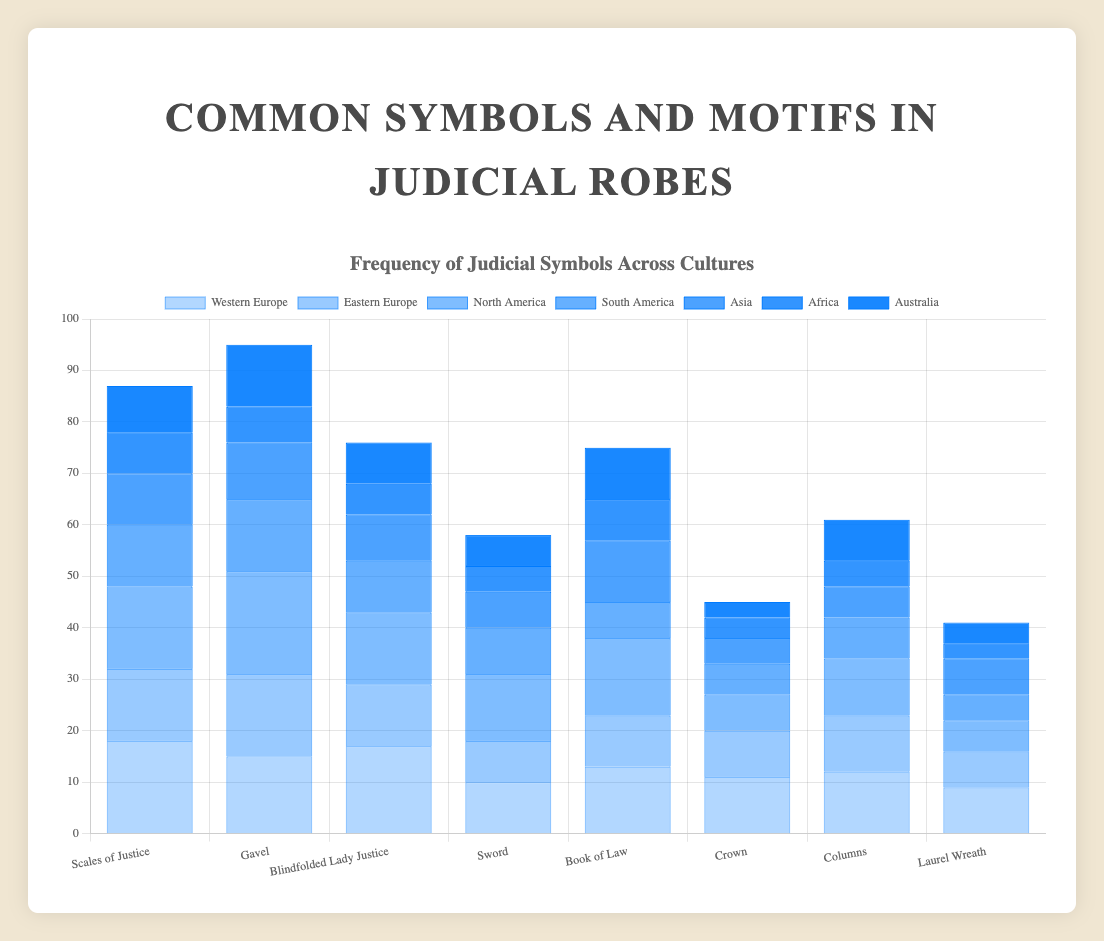Which culture features the "Scales of Justice" most frequently? By looking at the bars for the "Scales of Justice" symbol, we note the tallest bar represents Western Europe.
Answer: Western Europe Which symbol appears the least frequently overall? Scan across all symbols and their frequencies; the "Crown" has the consistently smallest values overall.
Answer: Crown What are the average frequencies of the "Book of Law" across all cultures? Sum up the frequencies for "Book of Law" across all regions and divide by the total number of regions (7): (13 + 10 + 15 + 7 + 12 + 8 + 10) / 7 = 75 / 7.
Answer: 10.71 Which region has the most consistent symbol frequencies (i.e., smallest range between highest and lowest frequencies)? Calculate the range for each region by subtracting the smallest frequency from the largest for all symbols in that region. The most consistent region will have the smallest range.
Answer: Africa (range = 8 - 3 = 5) How does the frequency of "Gavel" in North America compare to its frequency in Africa? Compare the height of the bars for "Gavel" in North America and Africa. North America's bar is significantly taller than Africa's.
Answer: North America > Africa What is the total frequency of the "Sword" and "Columns" symbols in Western Europe? Sum the "Sword" and "Columns" frequencies in Western Europe: 10 + 12.
Answer: 22 Out of all the symbols, which one has the highest frequency in a single region, and what is that value? Look for the tallest bar across all symbols and regions. The "Gavel" in North America has the highest frequency with a value of 20.
Answer: Gavel, 20 Which culture depicts the "Blindfolded Lady Justice" the least? Identify the region with the smallest bar for "Blindfolded Lady Justice." Africa has the smallest bar.
Answer: Africa Is the "Scales of Justice" more common in Western Europe or Eastern Europe? Compare the heights of the "Scales of Justice" bars for Western Europe and Eastern Europe. Western Europe's bar is taller.
Answer: Western Europe 